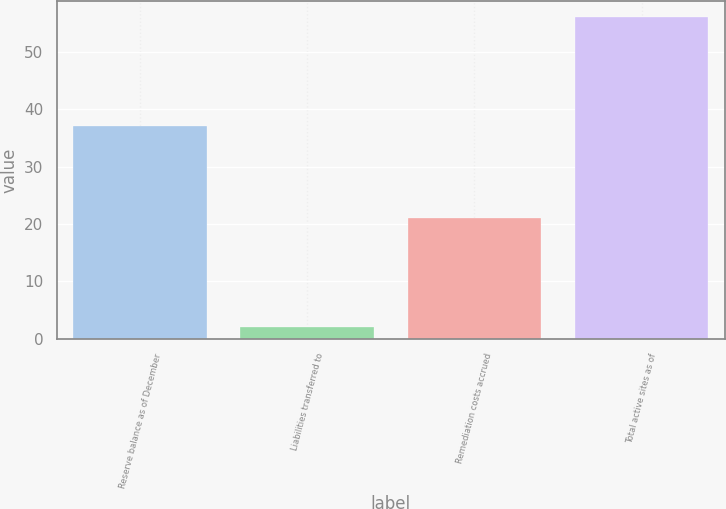Convert chart to OTSL. <chart><loc_0><loc_0><loc_500><loc_500><bar_chart><fcel>Reserve balance as of December<fcel>Liabilities transferred to<fcel>Remediation costs accrued<fcel>Total active sites as of<nl><fcel>37<fcel>2<fcel>21<fcel>56<nl></chart> 